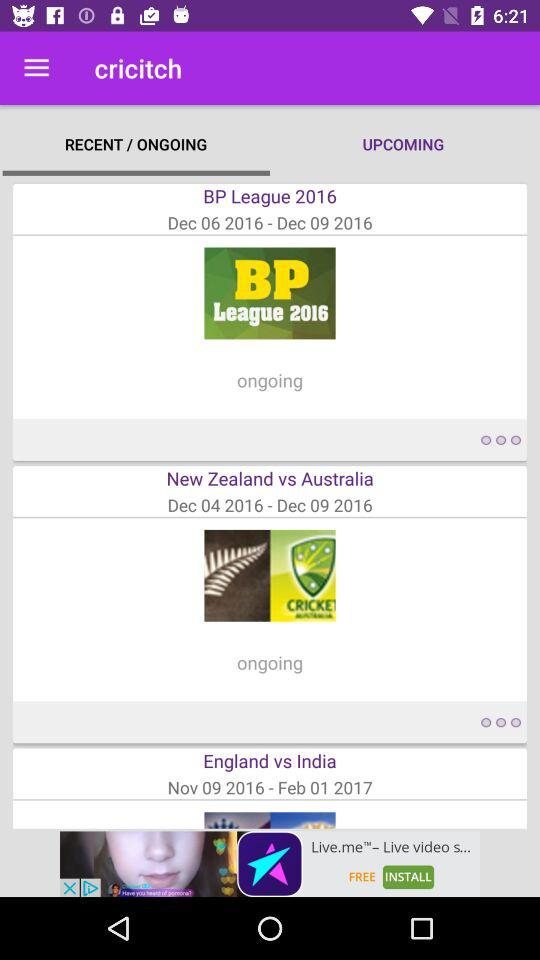From what date will the "BP League" start? The "BP League" will start from December 6, 2016. 